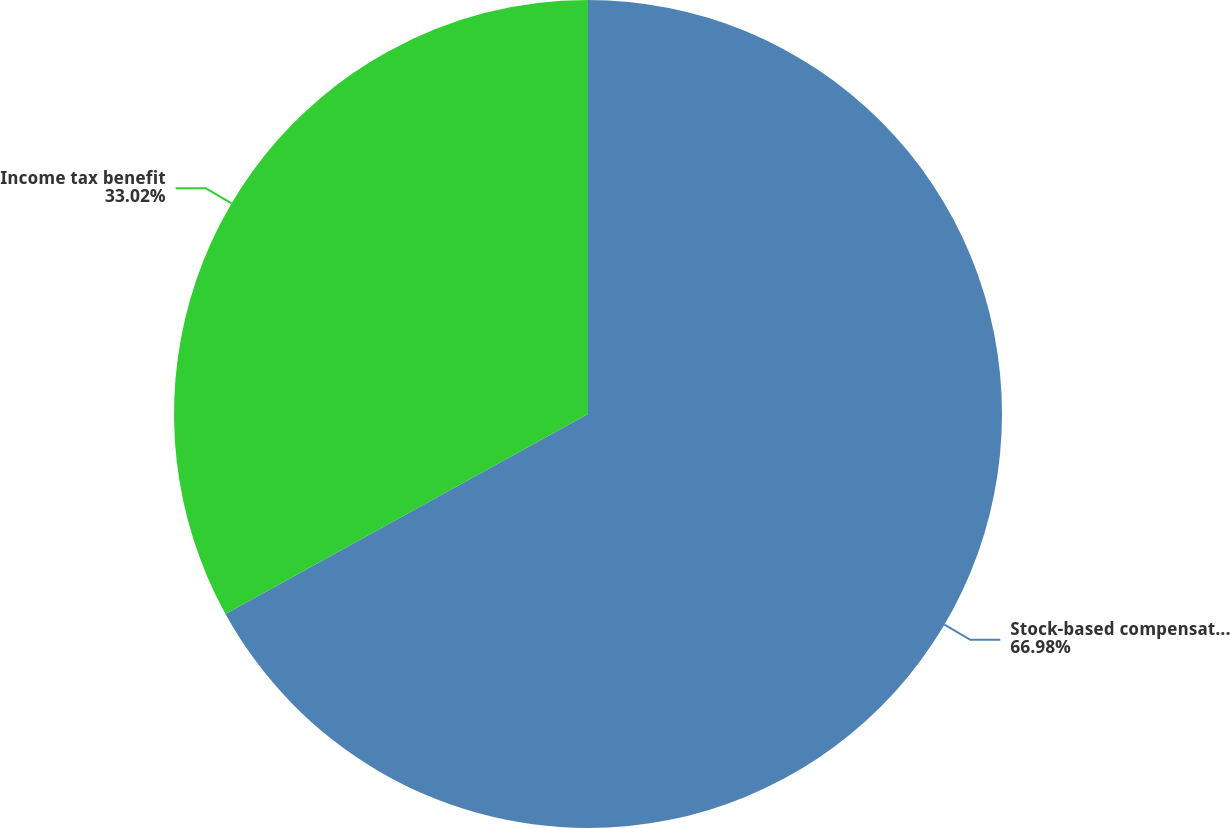Convert chart to OTSL. <chart><loc_0><loc_0><loc_500><loc_500><pie_chart><fcel>Stock-based compensation<fcel>Income tax benefit<nl><fcel>66.98%<fcel>33.02%<nl></chart> 